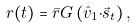<formula> <loc_0><loc_0><loc_500><loc_500>r ( t ) = { \bar { r } } G \left ( { \hat { v } } _ { 1 } { \cdot } { \vec { s } } _ { t } \right ) ,</formula> 